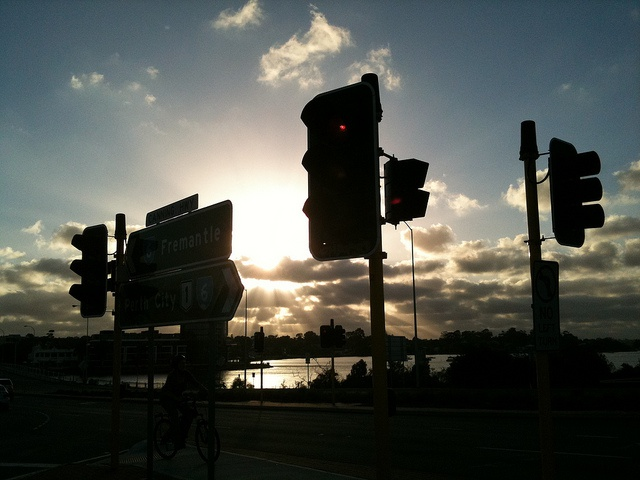Describe the objects in this image and their specific colors. I can see traffic light in darkblue, black, ivory, darkgray, and gray tones, traffic light in darkblue, black, gray, and tan tones, bicycle in darkblue and black tones, and traffic light in darkblue, black, darkgreen, and gray tones in this image. 